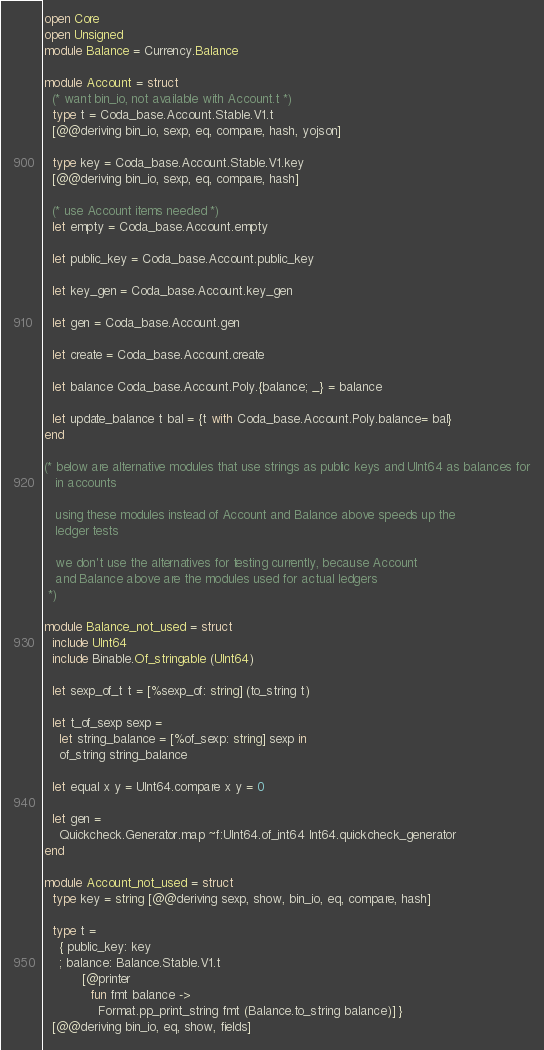Convert code to text. <code><loc_0><loc_0><loc_500><loc_500><_OCaml_>open Core
open Unsigned
module Balance = Currency.Balance

module Account = struct
  (* want bin_io, not available with Account.t *)
  type t = Coda_base.Account.Stable.V1.t
  [@@deriving bin_io, sexp, eq, compare, hash, yojson]

  type key = Coda_base.Account.Stable.V1.key
  [@@deriving bin_io, sexp, eq, compare, hash]

  (* use Account items needed *)
  let empty = Coda_base.Account.empty

  let public_key = Coda_base.Account.public_key

  let key_gen = Coda_base.Account.key_gen

  let gen = Coda_base.Account.gen

  let create = Coda_base.Account.create

  let balance Coda_base.Account.Poly.{balance; _} = balance

  let update_balance t bal = {t with Coda_base.Account.Poly.balance= bal}
end

(* below are alternative modules that use strings as public keys and UInt64 as balances for
   in accounts

   using these modules instead of Account and Balance above speeds up the
   ledger tests

   we don't use the alternatives for testing currently, because Account
   and Balance above are the modules used for actual ledgers
 *)

module Balance_not_used = struct
  include UInt64
  include Binable.Of_stringable (UInt64)

  let sexp_of_t t = [%sexp_of: string] (to_string t)

  let t_of_sexp sexp =
    let string_balance = [%of_sexp: string] sexp in
    of_string string_balance

  let equal x y = UInt64.compare x y = 0

  let gen =
    Quickcheck.Generator.map ~f:UInt64.of_int64 Int64.quickcheck_generator
end

module Account_not_used = struct
  type key = string [@@deriving sexp, show, bin_io, eq, compare, hash]

  type t =
    { public_key: key
    ; balance: Balance.Stable.V1.t
          [@printer
            fun fmt balance ->
              Format.pp_print_string fmt (Balance.to_string balance)] }
  [@@deriving bin_io, eq, show, fields]
</code> 